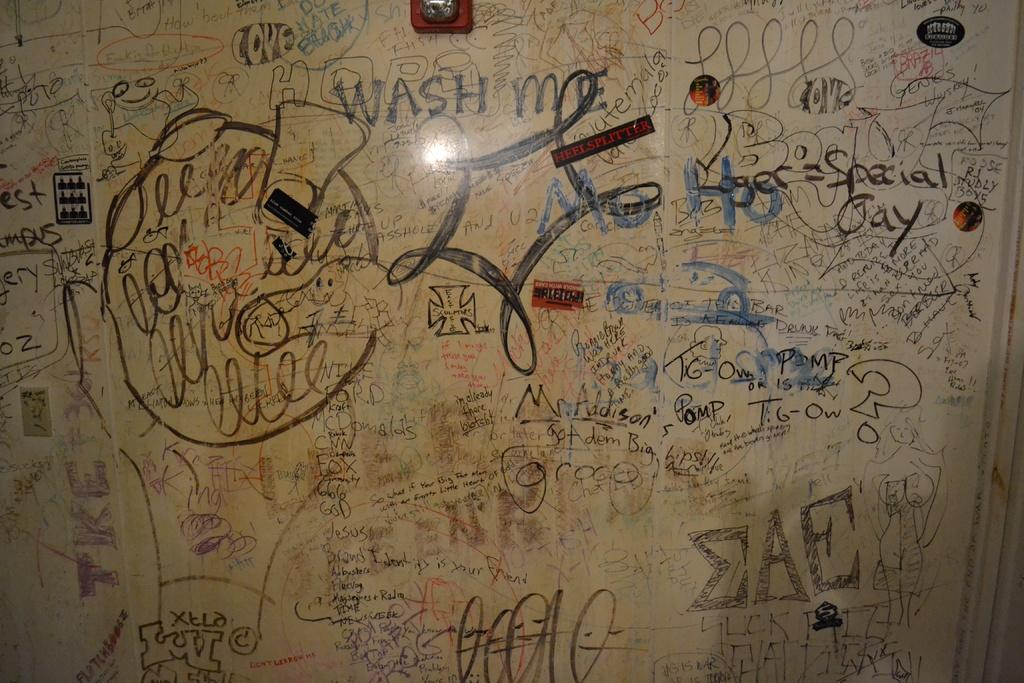<image>
Summarize the visual content of the image. A white board is full of scribbles and words including wash me. 